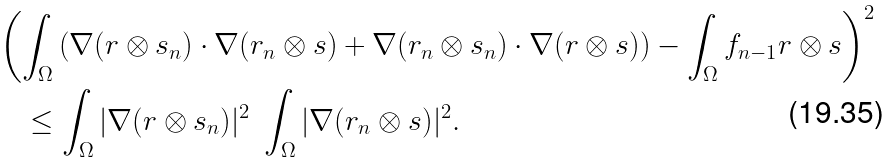Convert formula to latex. <formula><loc_0><loc_0><loc_500><loc_500>& \left ( \int _ { \Omega } \left ( \nabla ( r \otimes s _ { n } ) \cdot \nabla ( r _ { n } \otimes s ) + \nabla ( r _ { n } \otimes s _ { n } ) \cdot \nabla ( r \otimes s ) \right ) - \int _ { \Omega } f _ { n - 1 } r \otimes s \right ) ^ { 2 } \\ & \quad \leq \int _ { \Omega } | \nabla ( r \otimes s _ { n } ) | ^ { 2 } \ \int _ { \Omega } | \nabla ( r _ { n } \otimes s ) | ^ { 2 } .</formula> 